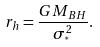Convert formula to latex. <formula><loc_0><loc_0><loc_500><loc_500>r _ { h } = \frac { G M _ { B H } } { \sigma _ { ^ { * } } ^ { 2 } } .</formula> 